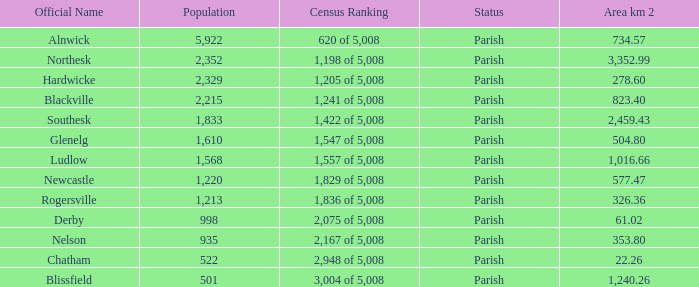Could you parse the entire table? {'header': ['Official Name', 'Population', 'Census Ranking', 'Status', 'Area km 2'], 'rows': [['Alnwick', '5,922', '620 of 5,008', 'Parish', '734.57'], ['Northesk', '2,352', '1,198 of 5,008', 'Parish', '3,352.99'], ['Hardwicke', '2,329', '1,205 of 5,008', 'Parish', '278.60'], ['Blackville', '2,215', '1,241 of 5,008', 'Parish', '823.40'], ['Southesk', '1,833', '1,422 of 5,008', 'Parish', '2,459.43'], ['Glenelg', '1,610', '1,547 of 5,008', 'Parish', '504.80'], ['Ludlow', '1,568', '1,557 of 5,008', 'Parish', '1,016.66'], ['Newcastle', '1,220', '1,829 of 5,008', 'Parish', '577.47'], ['Rogersville', '1,213', '1,836 of 5,008', 'Parish', '326.36'], ['Derby', '998', '2,075 of 5,008', 'Parish', '61.02'], ['Nelson', '935', '2,167 of 5,008', 'Parish', '353.80'], ['Chatham', '522', '2,948 of 5,008', 'Parish', '22.26'], ['Blissfield', '501', '3,004 of 5,008', 'Parish', '1,240.26']]} Can you tell me the sum of Area km 2 that has the Official Name of glenelg? 504.8. 